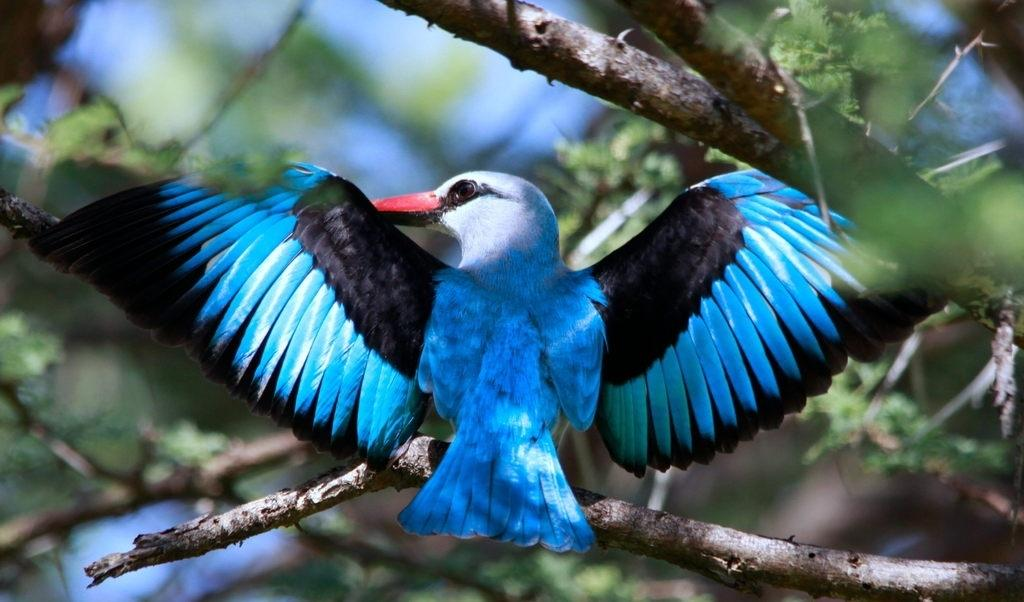What is the main subject of the image? There is a bird on a branch in the image. Can you describe the bird's location in the image? The bird is on a branch. What can be observed about the background of the image? The background of the image is blurred. What type of record can be seen in the bird's beak in the image? There is no record or beak present in the image; it features a bird on a branch with a blurred background. 